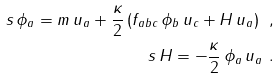<formula> <loc_0><loc_0><loc_500><loc_500>s \, \phi _ { a } = m \, u _ { a } + \frac { \kappa } { 2 } \, ( f _ { a b c } \, \phi _ { b } \, u _ { c } + H \, u _ { a } ) \ , \\ s \, H = - \frac { \kappa } { 2 } \, \phi _ { a } \, u _ { a } \ .</formula> 